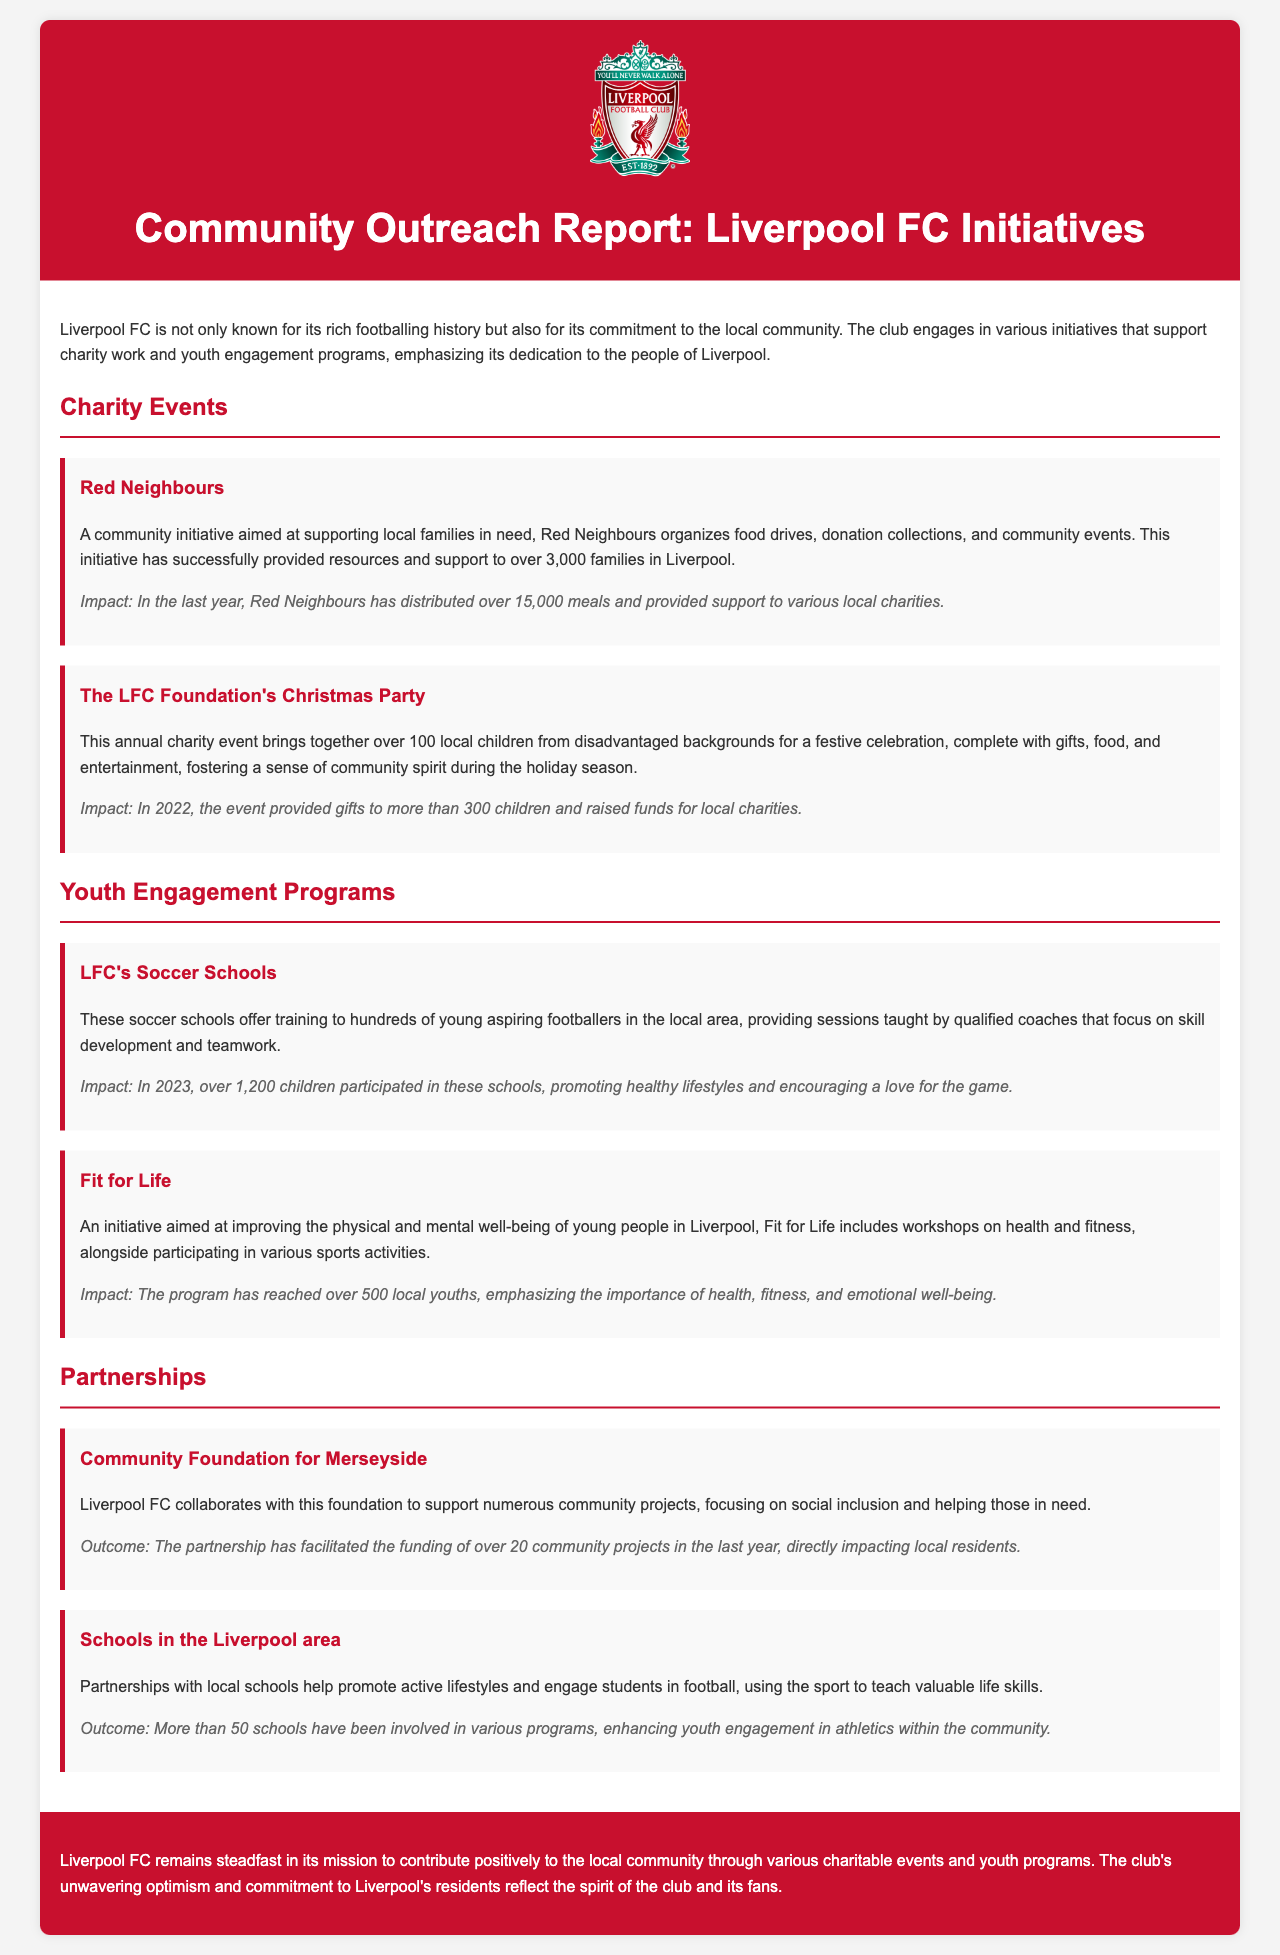What is the name of the community initiative aimed at supporting local families? The document mentions "Red Neighbours" as a community initiative aimed at supporting local families in need.
Answer: Red Neighbours How many families has Red Neighbours supported? According to the document, Red Neighbours has provided resources and support to over 3,000 families in Liverpool.
Answer: Over 3,000 families What event does The LFC Foundation organize for local children? The annual event organized is known as "The LFC Foundation's Christmas Party," which celebrates local children from disadvantaged backgrounds.
Answer: The LFC Foundation's Christmas Party How many children participated in LFC's Soccer Schools in 2023? The document states that over 1,200 children participated in LFC's Soccer Schools in 2023.
Answer: Over 1,200 children What is the goal of the "Fit for Life" initiative? The initiative aims to improve the physical and mental well-being of young people in Liverpool.
Answer: Improve physical and mental well-being How many community projects did the Community Foundation for Merseyside's partnership facilitate funding for? It is mentioned that the partnership has facilitated the funding of over 20 community projects in the last year.
Answer: Over 20 community projects What does the partnership with local schools promote? The partnerships with local schools help promote active lifestyles and engage students in football.
Answer: Active lifestyles What is the overall mission of Liverpool FC's community initiatives? The report concludes by stating that Liverpool FC aims to contribute positively to the local community through charitable events and youth programs.
Answer: Contribute positively to the local community 